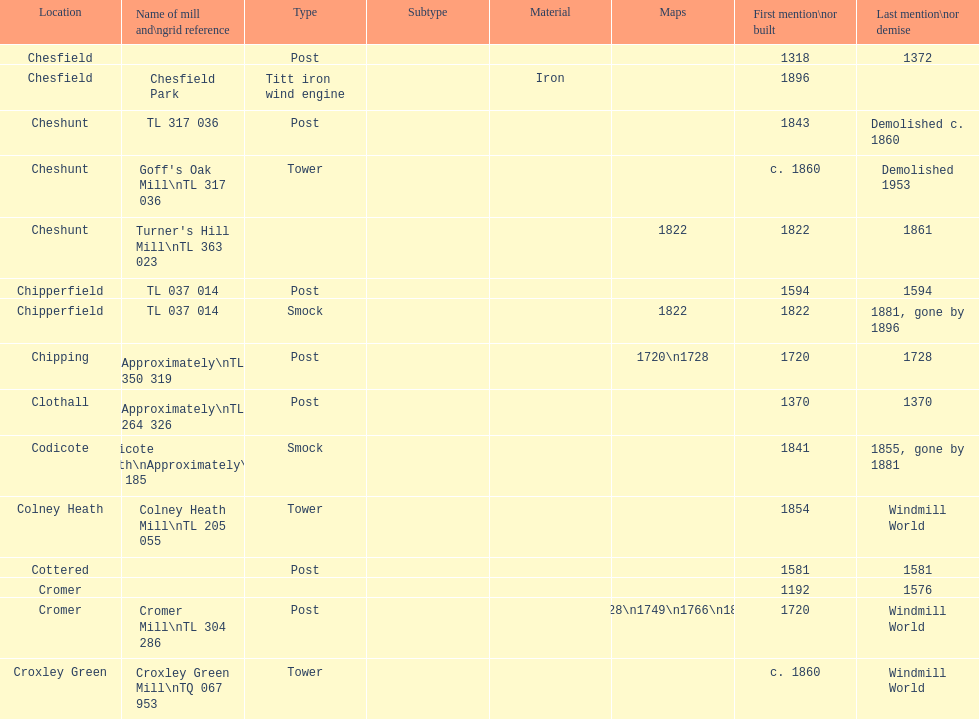How man "c" windmills have there been? 15. 